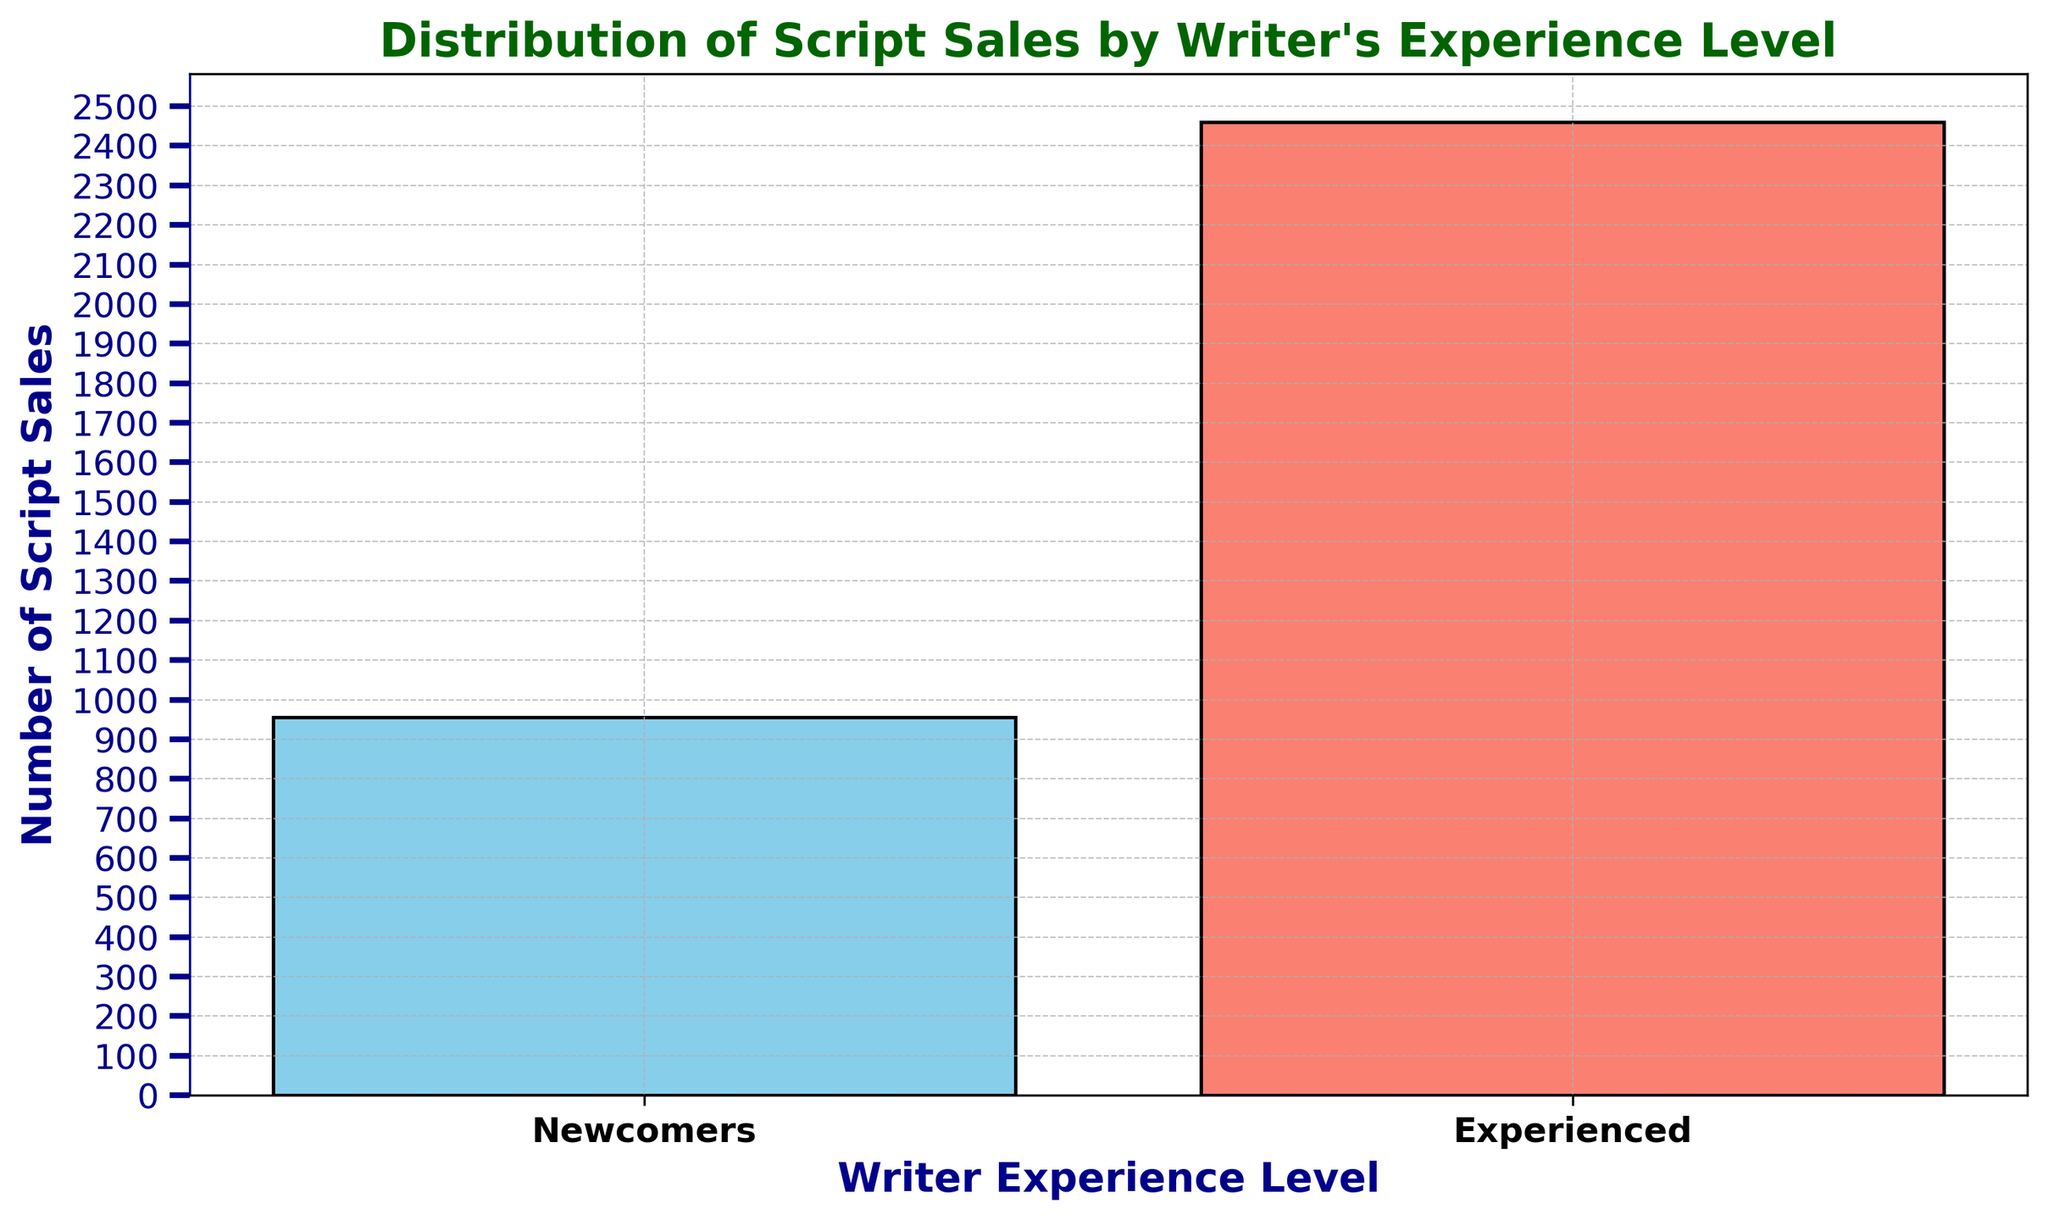What is the total number of script sales for each experience level? Aggregate the sales associated with each experience level by adding all the values provided. For Newcomers, it's 150 + 180 + 160 + 140 + 155 + 170 = 955. For Experienced, it's 400 + 420 + 410 + 395 + 430 + 405 = 2460.
Answer: Newcomers: 955, Experienced: 2460 Which group has the higher total number of script sales, Newcomers or Experienced writers? Compare the summed script sales totals for each group. Newcomers have 955 sales, and Experienced writers have 2460 sales.
Answer: Experienced writers What is the average number of script sales for Newcomers? Sum the sales for Newcomers (955) and divide by the number of data points (6): 955 / 6 = 159.17.
Answer: 159.17 What is the difference in total script sales between Newcomers and Experienced writers? Subtract the total sales of Newcomers (955) from Experienced writers (2460): 2460 - 955 = 1505.
Answer: 1505 Which experience level is represented by the red-colored bar? By visually inspecting the bar chart, identify which group corresponds to the red-colored bar in the figure.
Answer: Experienced writers What is the height of the bar representing the total sales for Newcomers? Observe the vertical height of the blue-colored bar. This height equals the total sales for Newcomers, which is 955.
Answer: 955 How many script sales do Experienced writers have more than Newcomers on average? First, calculate the average sales for Newcomers (159.17) and for Experienced writers (410). Then subtract the Newcomers' average from the Experienced writers' average: 410 - 159.17 = 250.83.
Answer: 250.83 What does the y-axis of the bar chart represent? Visually inspect the chart to determine the label and values on the vertical (y) axis of the bar chart. It represents the "Number of Script Sales" from the provided data.
Answer: Number of Script Sales 